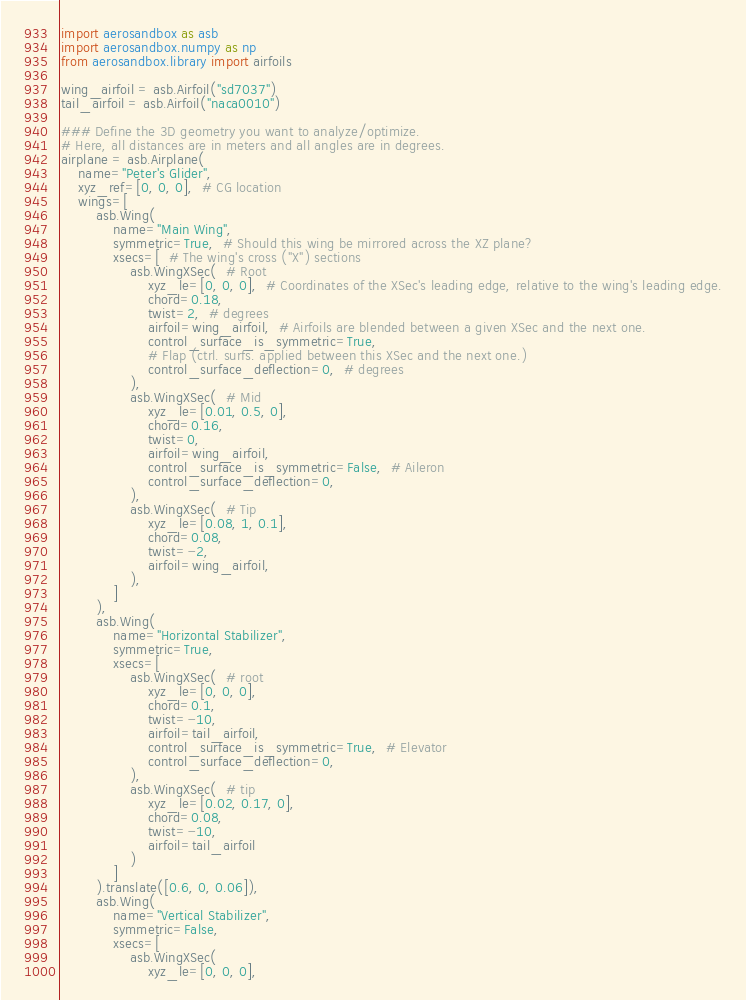Convert code to text. <code><loc_0><loc_0><loc_500><loc_500><_Python_>import aerosandbox as asb
import aerosandbox.numpy as np
from aerosandbox.library import airfoils

wing_airfoil = asb.Airfoil("sd7037")
tail_airfoil = asb.Airfoil("naca0010")

### Define the 3D geometry you want to analyze/optimize.
# Here, all distances are in meters and all angles are in degrees.
airplane = asb.Airplane(
    name="Peter's Glider",
    xyz_ref=[0, 0, 0],  # CG location
    wings=[
        asb.Wing(
            name="Main Wing",
            symmetric=True,  # Should this wing be mirrored across the XZ plane?
            xsecs=[  # The wing's cross ("X") sections
                asb.WingXSec(  # Root
                    xyz_le=[0, 0, 0],  # Coordinates of the XSec's leading edge, relative to the wing's leading edge.
                    chord=0.18,
                    twist=2,  # degrees
                    airfoil=wing_airfoil,  # Airfoils are blended between a given XSec and the next one.
                    control_surface_is_symmetric=True,
                    # Flap (ctrl. surfs. applied between this XSec and the next one.)
                    control_surface_deflection=0,  # degrees
                ),
                asb.WingXSec(  # Mid
                    xyz_le=[0.01, 0.5, 0],
                    chord=0.16,
                    twist=0,
                    airfoil=wing_airfoil,
                    control_surface_is_symmetric=False,  # Aileron
                    control_surface_deflection=0,
                ),
                asb.WingXSec(  # Tip
                    xyz_le=[0.08, 1, 0.1],
                    chord=0.08,
                    twist=-2,
                    airfoil=wing_airfoil,
                ),
            ]
        ),
        asb.Wing(
            name="Horizontal Stabilizer",
            symmetric=True,
            xsecs=[
                asb.WingXSec(  # root
                    xyz_le=[0, 0, 0],
                    chord=0.1,
                    twist=-10,
                    airfoil=tail_airfoil,
                    control_surface_is_symmetric=True,  # Elevator
                    control_surface_deflection=0,
                ),
                asb.WingXSec(  # tip
                    xyz_le=[0.02, 0.17, 0],
                    chord=0.08,
                    twist=-10,
                    airfoil=tail_airfoil
                )
            ]
        ).translate([0.6, 0, 0.06]),
        asb.Wing(
            name="Vertical Stabilizer",
            symmetric=False,
            xsecs=[
                asb.WingXSec(
                    xyz_le=[0, 0, 0],</code> 